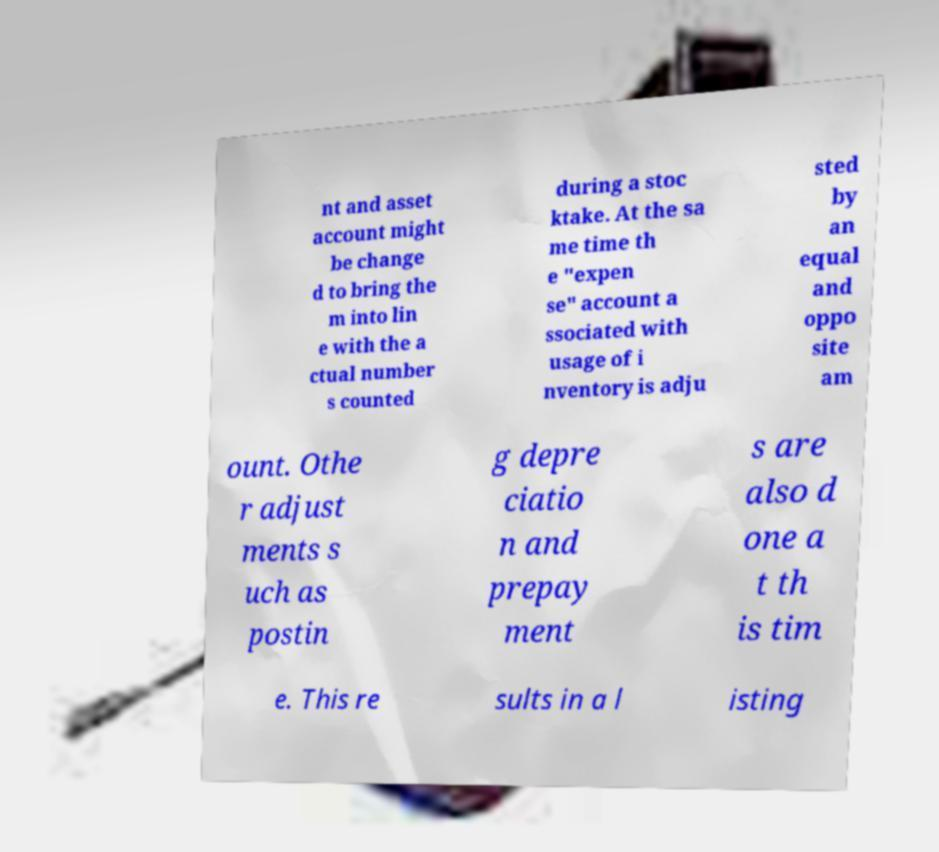Could you assist in decoding the text presented in this image and type it out clearly? nt and asset account might be change d to bring the m into lin e with the a ctual number s counted during a stoc ktake. At the sa me time th e "expen se" account a ssociated with usage of i nventory is adju sted by an equal and oppo site am ount. Othe r adjust ments s uch as postin g depre ciatio n and prepay ment s are also d one a t th is tim e. This re sults in a l isting 